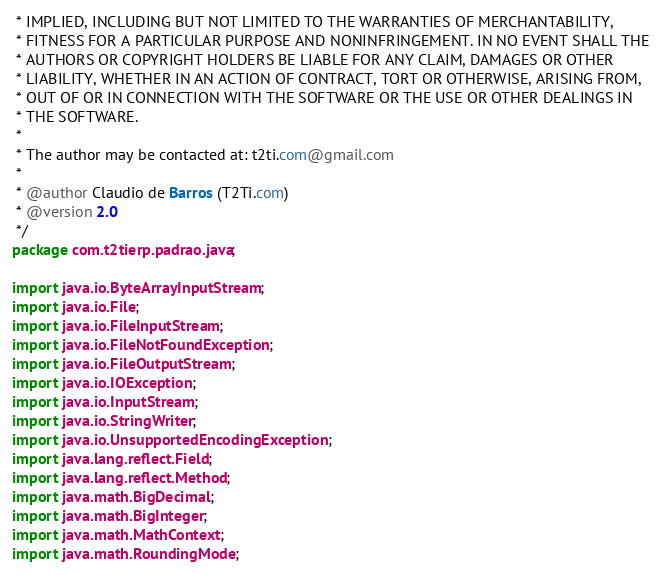<code> <loc_0><loc_0><loc_500><loc_500><_Java_> * IMPLIED, INCLUDING BUT NOT LIMITED TO THE WARRANTIES OF MERCHANTABILITY,
 * FITNESS FOR A PARTICULAR PURPOSE AND NONINFRINGEMENT. IN NO EVENT SHALL THE
 * AUTHORS OR COPYRIGHT HOLDERS BE LIABLE FOR ANY CLAIM, DAMAGES OR OTHER
 * LIABILITY, WHETHER IN AN ACTION OF CONTRACT, TORT OR OTHERWISE, ARISING FROM,
 * OUT OF OR IN CONNECTION WITH THE SOFTWARE OR THE USE OR OTHER DEALINGS IN
 * THE SOFTWARE.
 * 
 * The author may be contacted at: t2ti.com@gmail.com
 *
 * @author Claudio de Barros (T2Ti.com)
 * @version 2.0
 */
package com.t2tierp.padrao.java;

import java.io.ByteArrayInputStream;
import java.io.File;
import java.io.FileInputStream;
import java.io.FileNotFoundException;
import java.io.FileOutputStream;
import java.io.IOException;
import java.io.InputStream;
import java.io.StringWriter;
import java.io.UnsupportedEncodingException;
import java.lang.reflect.Field;
import java.lang.reflect.Method;
import java.math.BigDecimal;
import java.math.BigInteger;
import java.math.MathContext;
import java.math.RoundingMode;</code> 